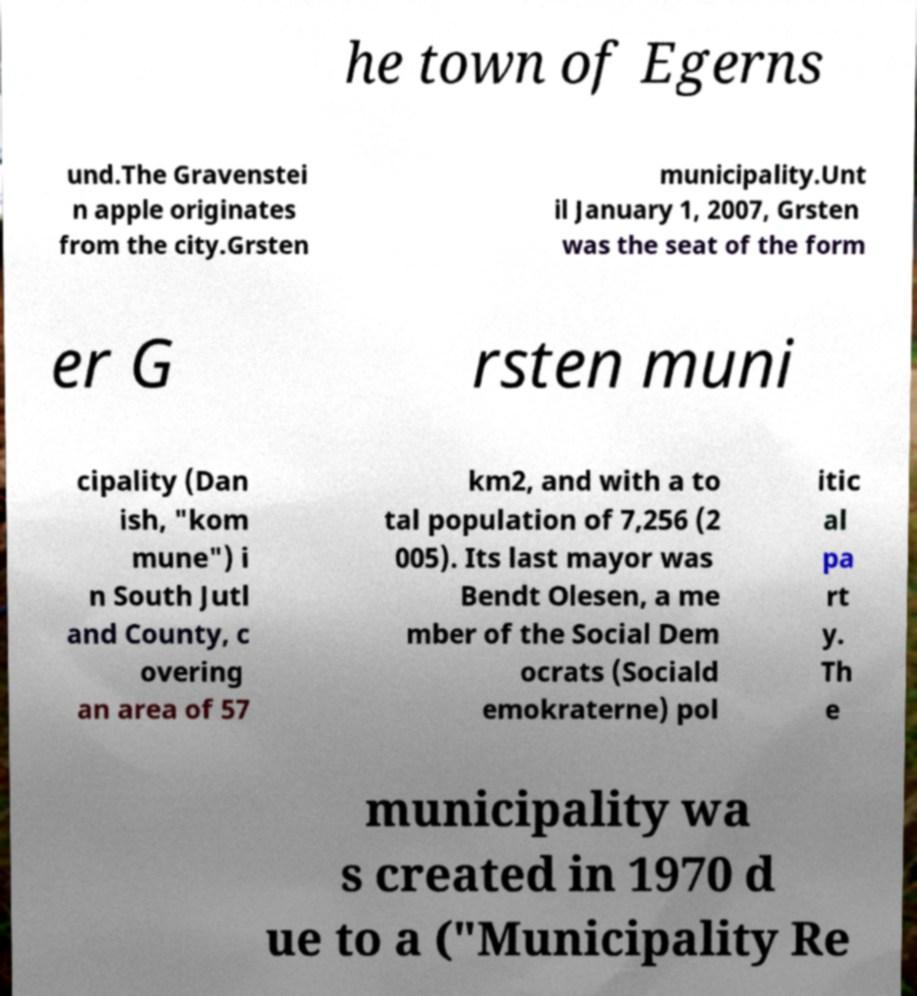Please identify and transcribe the text found in this image. he town of Egerns und.The Gravenstei n apple originates from the city.Grsten municipality.Unt il January 1, 2007, Grsten was the seat of the form er G rsten muni cipality (Dan ish, "kom mune") i n South Jutl and County, c overing an area of 57 km2, and with a to tal population of 7,256 (2 005). Its last mayor was Bendt Olesen, a me mber of the Social Dem ocrats (Sociald emokraterne) pol itic al pa rt y. Th e municipality wa s created in 1970 d ue to a ("Municipality Re 